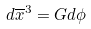Convert formula to latex. <formula><loc_0><loc_0><loc_500><loc_500>d \overline { x } ^ { 3 } = G d \phi</formula> 